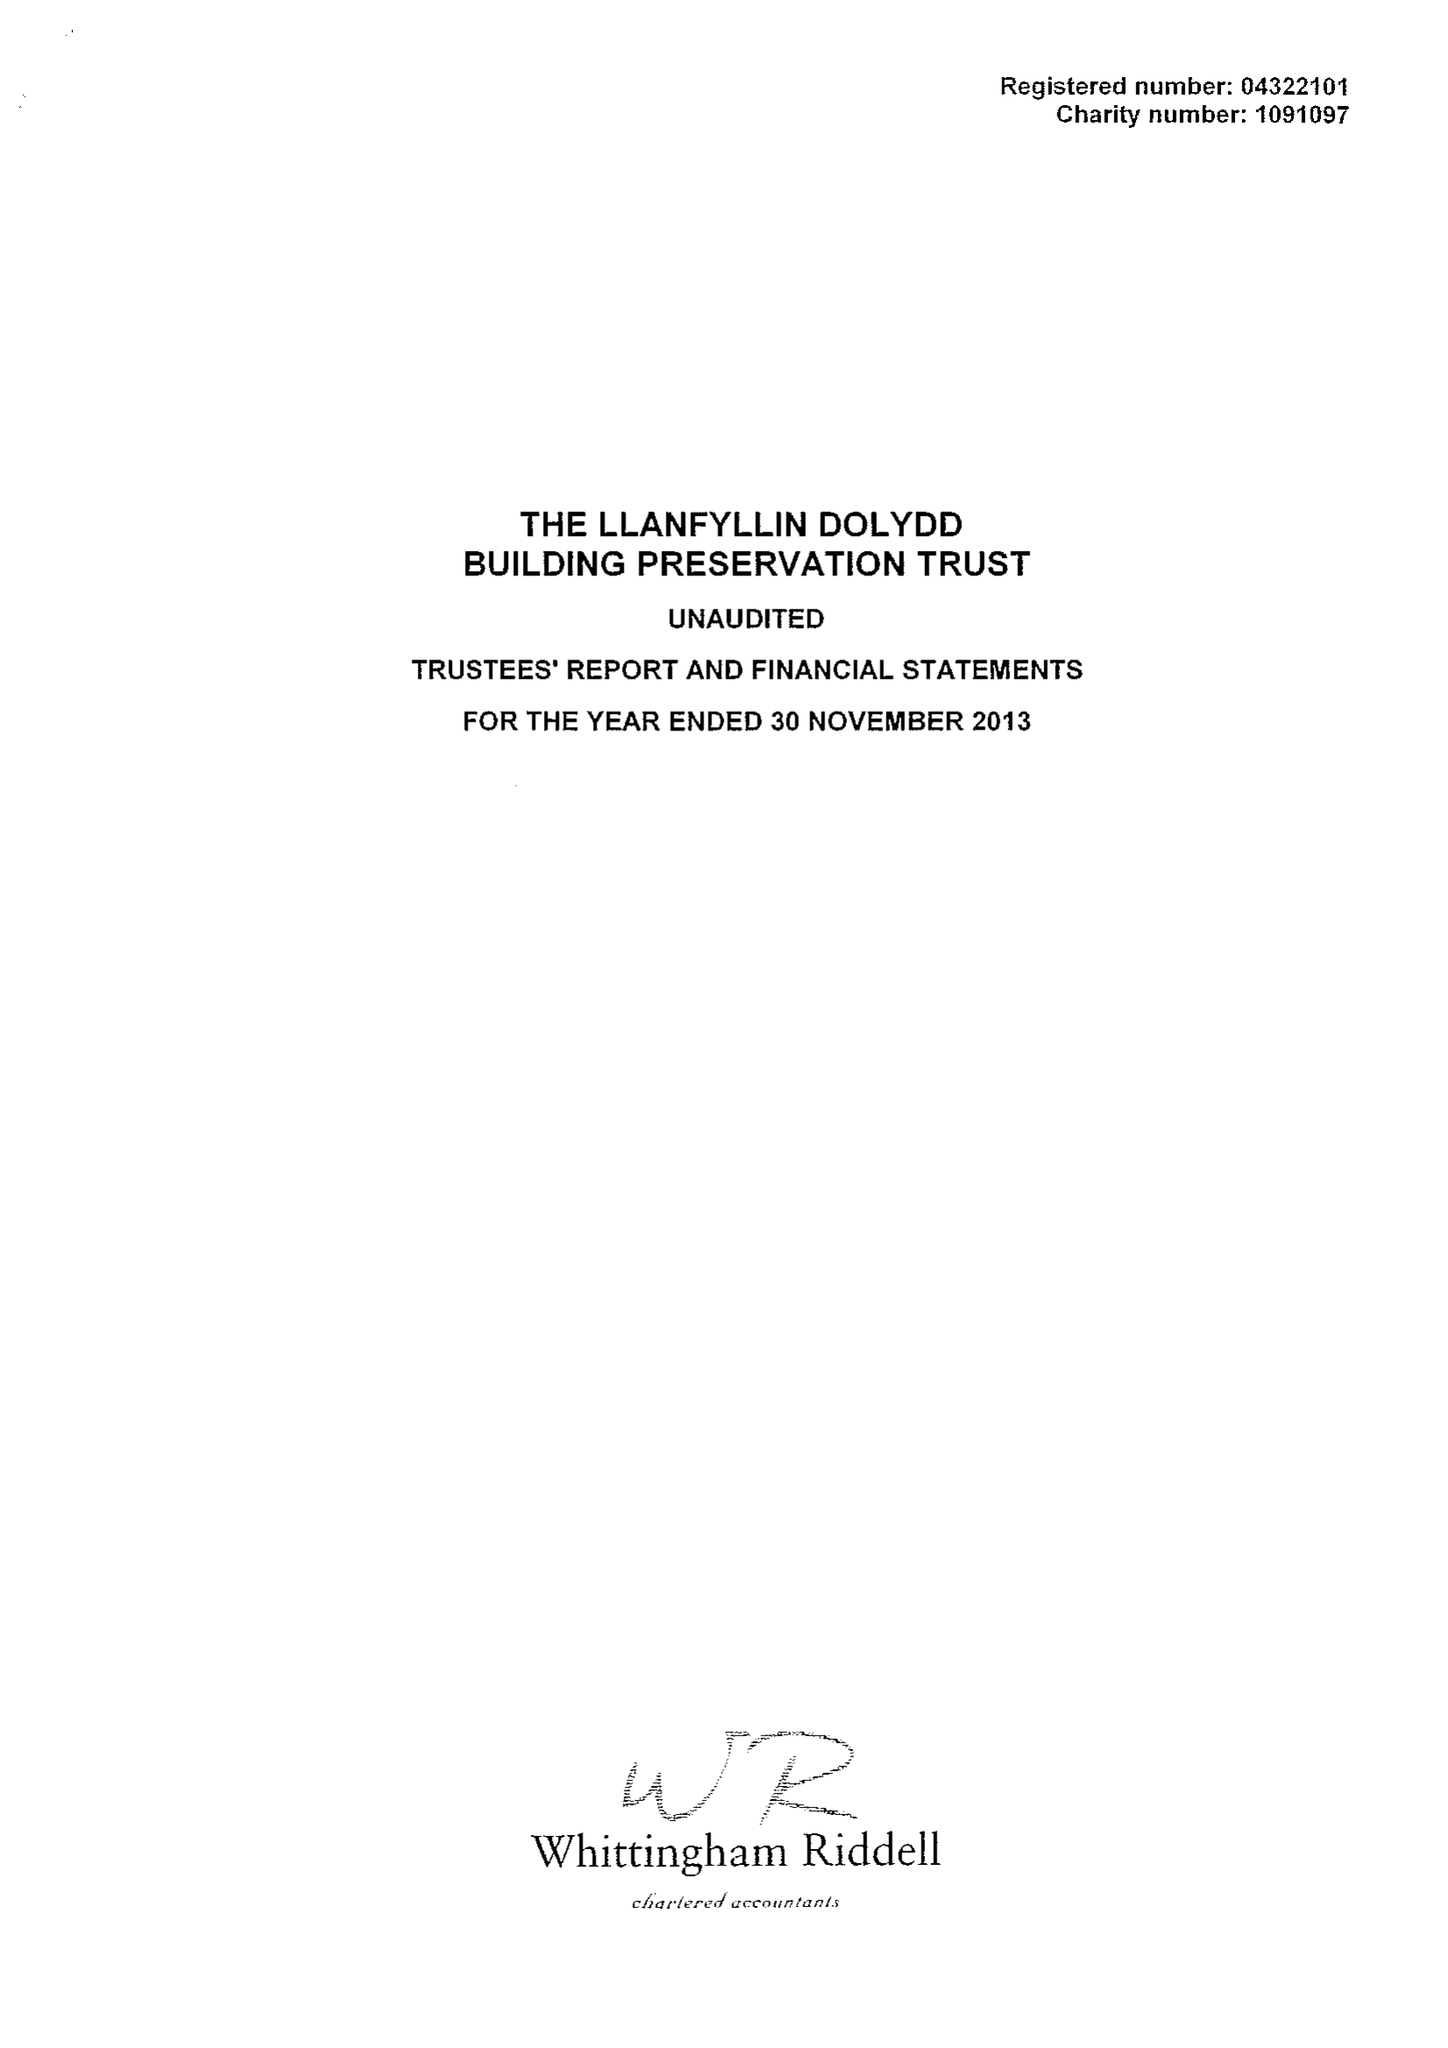What is the value for the report_date?
Answer the question using a single word or phrase. 2013-11-30 